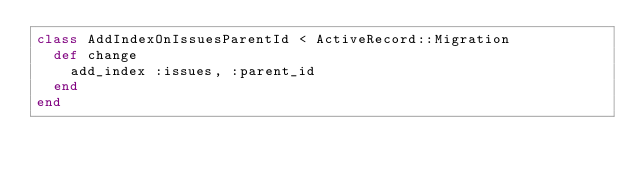<code> <loc_0><loc_0><loc_500><loc_500><_Ruby_>class AddIndexOnIssuesParentId < ActiveRecord::Migration
  def change
    add_index :issues, :parent_id
  end
end
</code> 